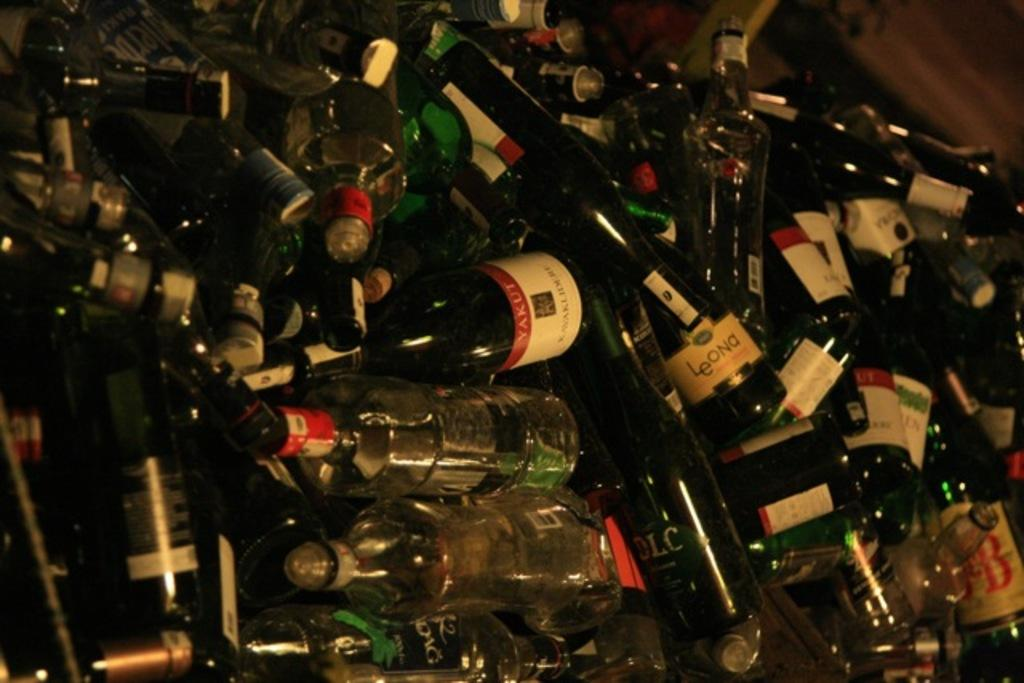<image>
Share a concise interpretation of the image provided. Several discarded bottles, including a bottle of Yakut. 